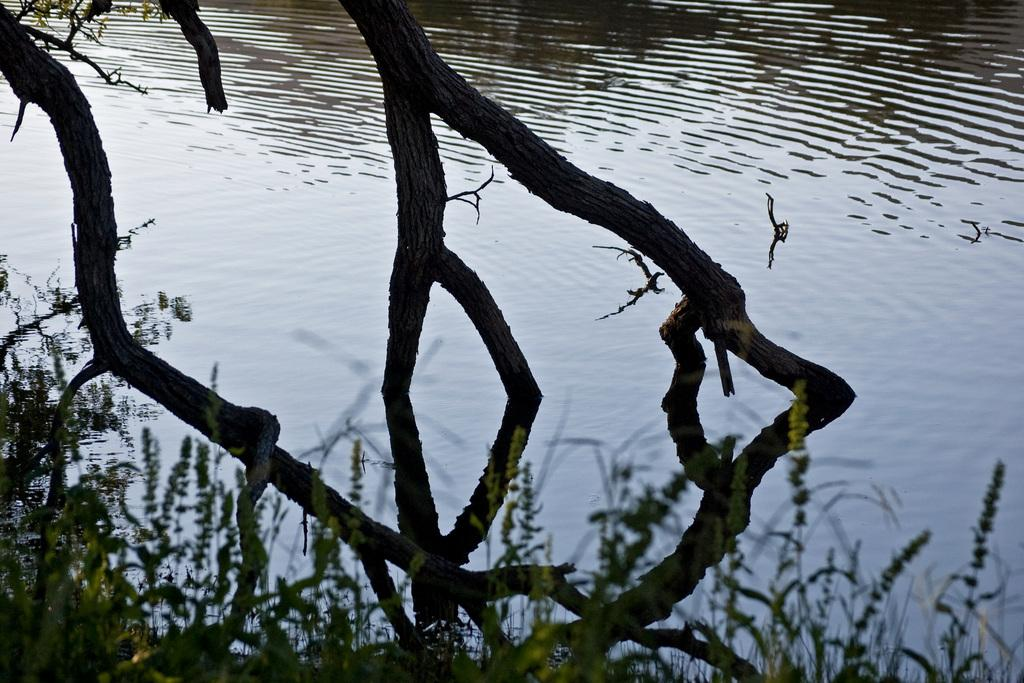What is the main subject in the center of the image? There is a tree in the center of the image. What can be seen in the background of the image? There is water visible in the background of the image. What type of net is being used to catch fish in the image? There is no net present in the image; it features a tree and water in the background. How is the connection between the tree and water established in the image? The image does not depict a direct connection between the tree and water; it simply shows a tree in the center and water in the background. 